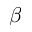<formula> <loc_0><loc_0><loc_500><loc_500>\beta</formula> 